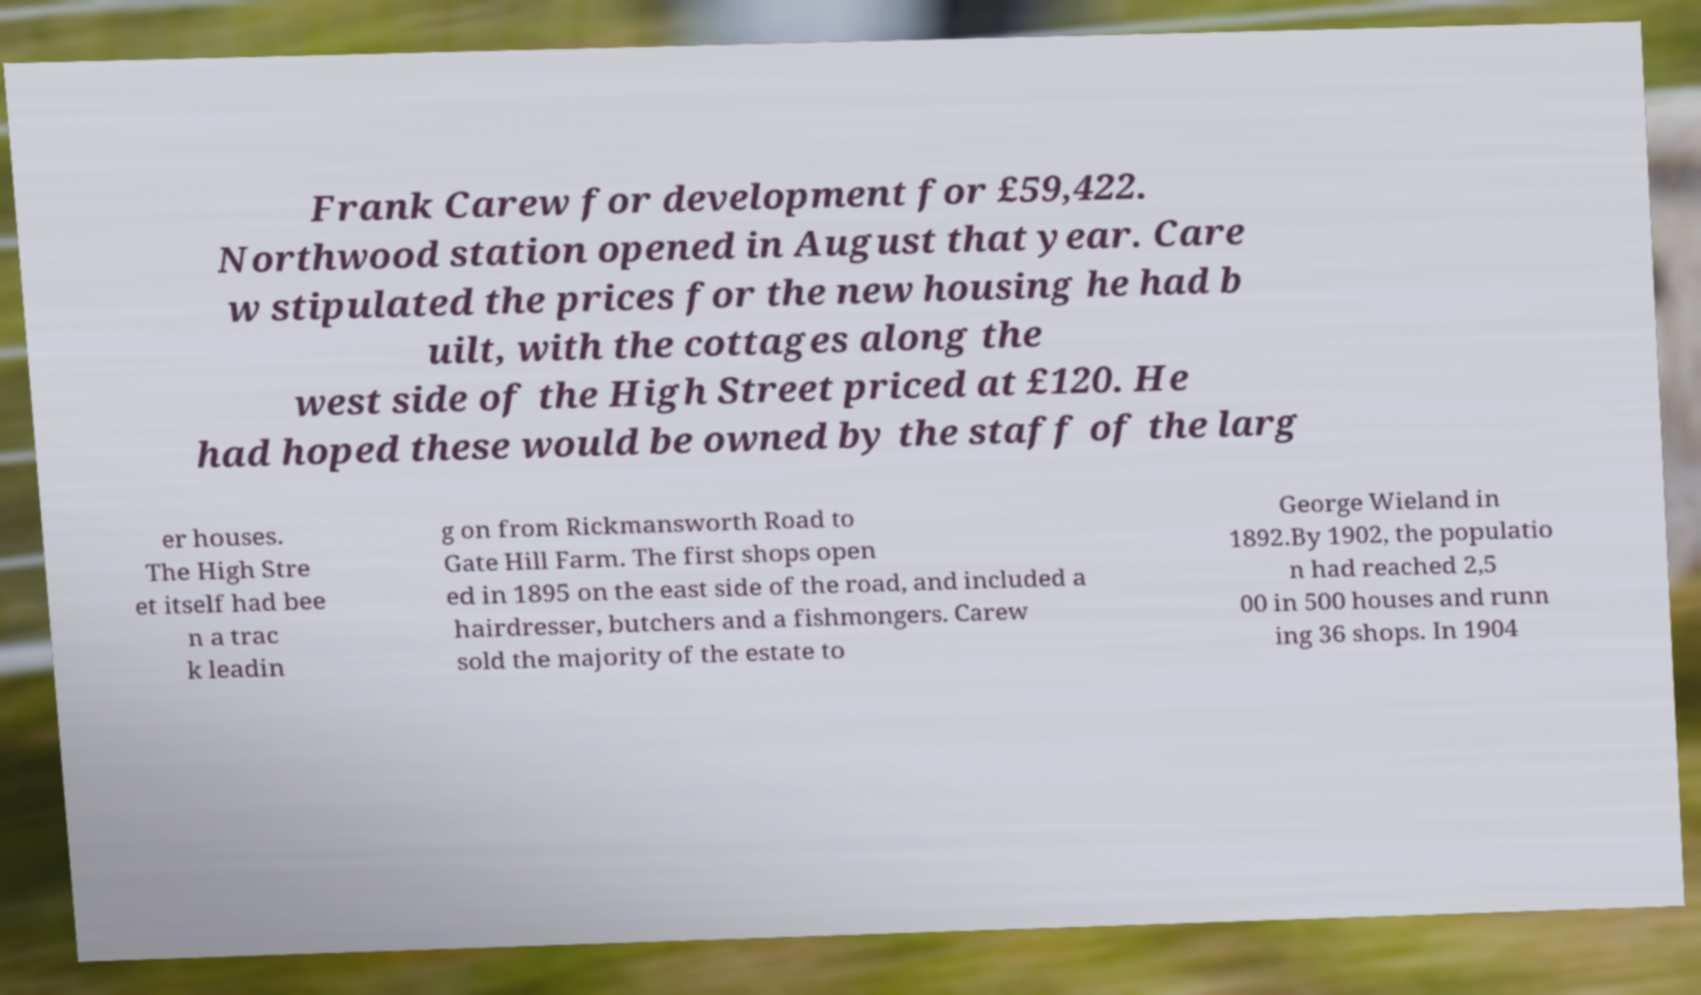What messages or text are displayed in this image? I need them in a readable, typed format. Frank Carew for development for £59,422. Northwood station opened in August that year. Care w stipulated the prices for the new housing he had b uilt, with the cottages along the west side of the High Street priced at £120. He had hoped these would be owned by the staff of the larg er houses. The High Stre et itself had bee n a trac k leadin g on from Rickmansworth Road to Gate Hill Farm. The first shops open ed in 1895 on the east side of the road, and included a hairdresser, butchers and a fishmongers. Carew sold the majority of the estate to George Wieland in 1892.By 1902, the populatio n had reached 2,5 00 in 500 houses and runn ing 36 shops. In 1904 